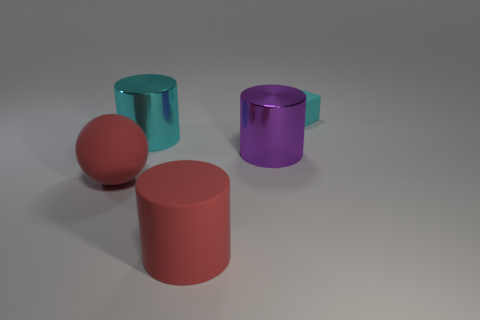The large rubber thing that is the same color as the ball is what shape?
Provide a succinct answer. Cylinder. What is the color of the other big metal thing that is the same shape as the big cyan object?
Keep it short and to the point. Purple. Does the shiny cylinder that is on the right side of the cyan cylinder have the same size as the rubber object in front of the red matte sphere?
Provide a succinct answer. Yes. Is there a large yellow rubber thing of the same shape as the large cyan metal thing?
Provide a succinct answer. No. Is the number of tiny things in front of the big red ball the same as the number of tiny cyan shiny spheres?
Keep it short and to the point. Yes. There is a red rubber sphere; is its size the same as the shiny cylinder on the left side of the purple metal cylinder?
Your response must be concise. Yes. How many small gray objects have the same material as the cyan cylinder?
Keep it short and to the point. 0. Do the red cylinder and the cyan cylinder have the same size?
Make the answer very short. Yes. Is there any other thing that is the same color as the rubber block?
Your response must be concise. Yes. The rubber object that is right of the cyan metal object and in front of the big purple object has what shape?
Give a very brief answer. Cylinder. 